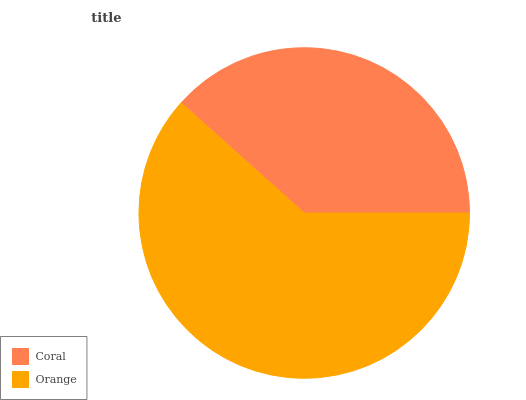Is Coral the minimum?
Answer yes or no. Yes. Is Orange the maximum?
Answer yes or no. Yes. Is Orange the minimum?
Answer yes or no. No. Is Orange greater than Coral?
Answer yes or no. Yes. Is Coral less than Orange?
Answer yes or no. Yes. Is Coral greater than Orange?
Answer yes or no. No. Is Orange less than Coral?
Answer yes or no. No. Is Orange the high median?
Answer yes or no. Yes. Is Coral the low median?
Answer yes or no. Yes. Is Coral the high median?
Answer yes or no. No. Is Orange the low median?
Answer yes or no. No. 